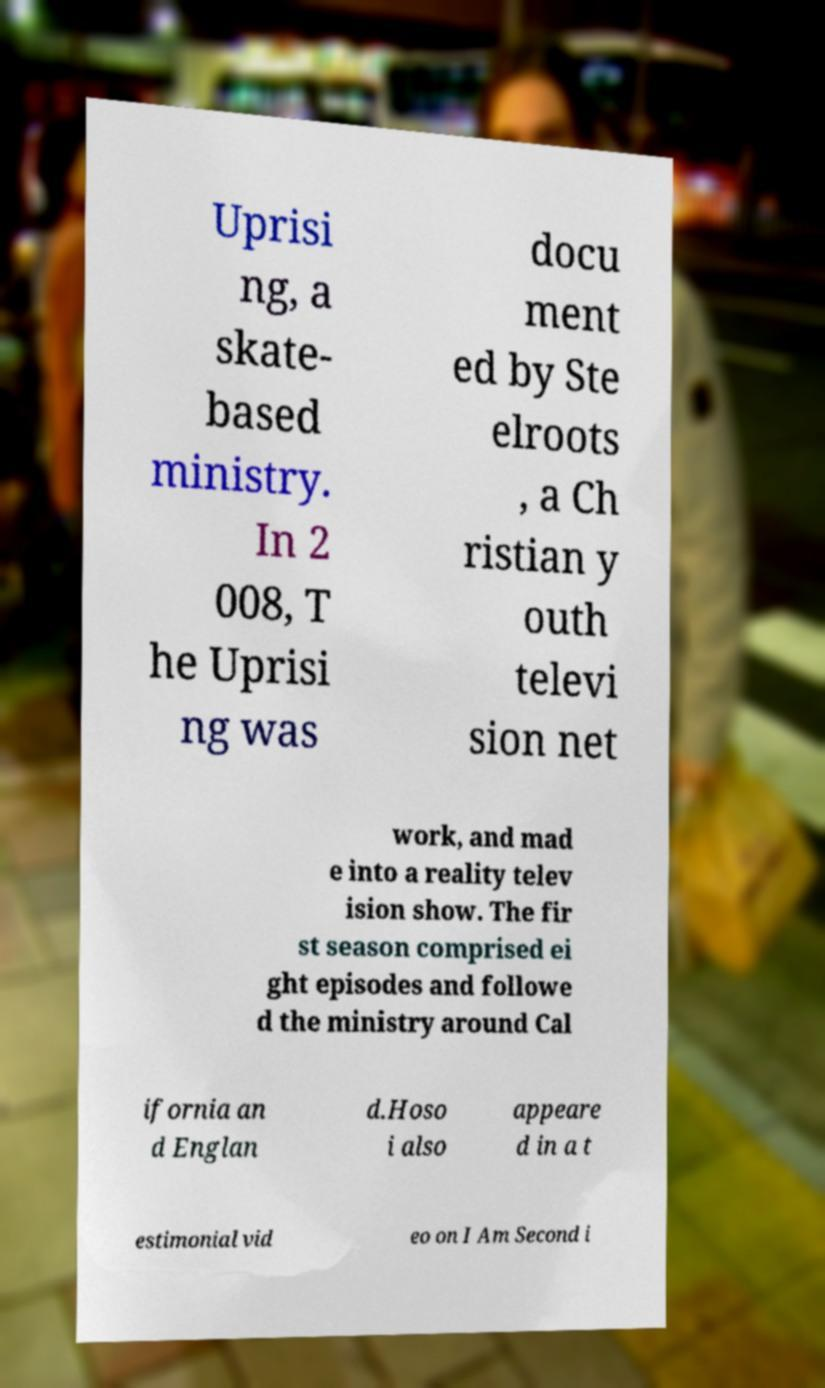Can you accurately transcribe the text from the provided image for me? Uprisi ng, a skate- based ministry. In 2 008, T he Uprisi ng was docu ment ed by Ste elroots , a Ch ristian y outh televi sion net work, and mad e into a reality telev ision show. The fir st season comprised ei ght episodes and followe d the ministry around Cal ifornia an d Englan d.Hoso i also appeare d in a t estimonial vid eo on I Am Second i 